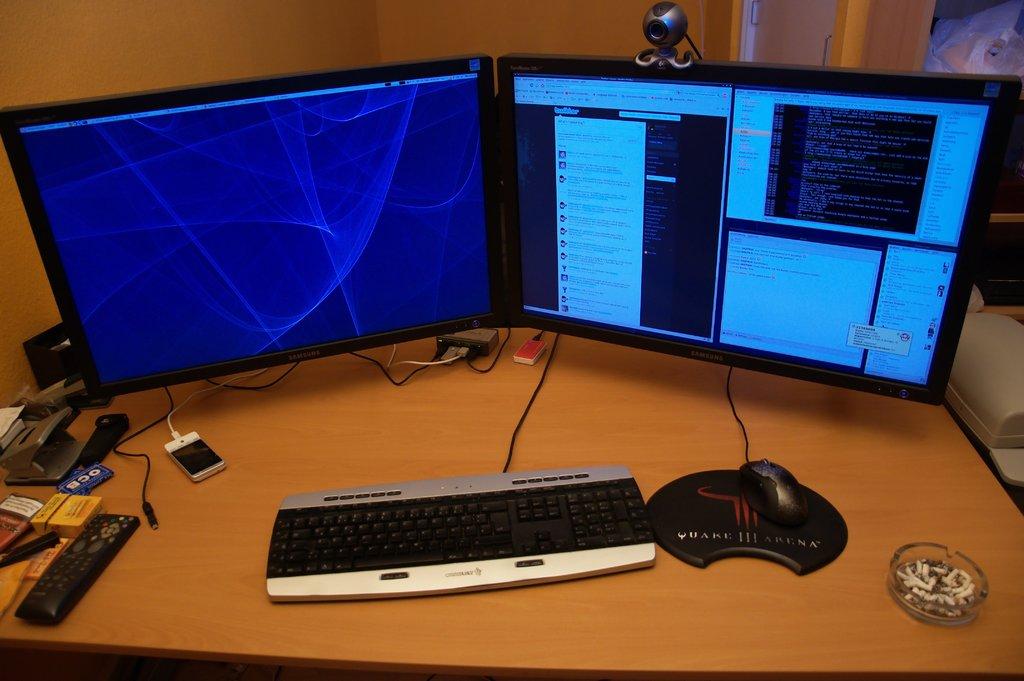What does the mousepad say?
Ensure brevity in your answer.  Quake arena. 